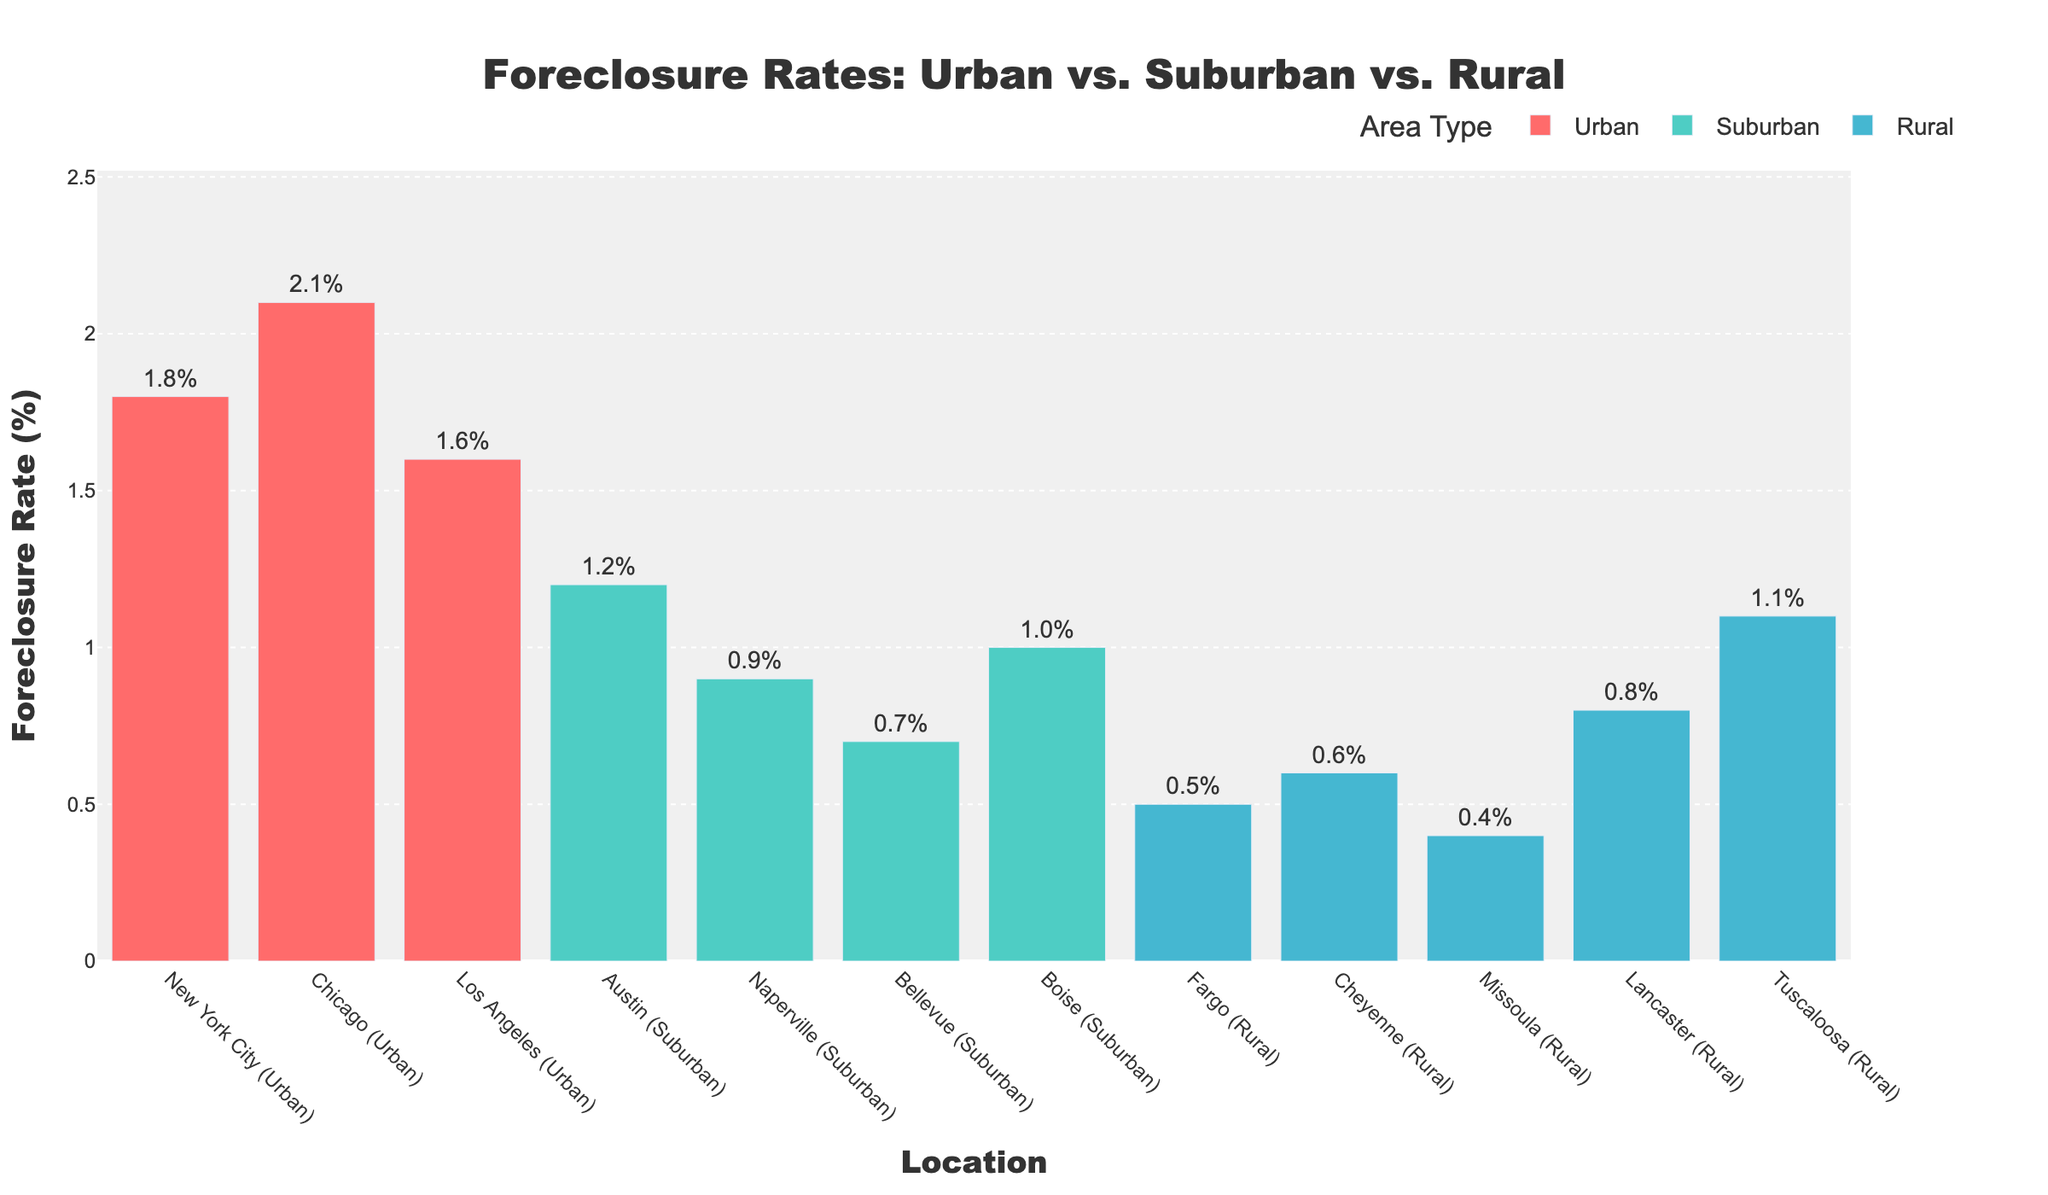Which area type has the highest foreclosure rate? By visually identifying the bars with the highest values and their corresponding area types, we see that the highest foreclosure rate is in Chicago, which is categorized as Urban.
Answer: Urban Which area type has the lowest foreclosure rate? By examining the shortest bars, we see that the lowest foreclosure rate is in Missoula, which is categorized as Rural.
Answer: Rural By how much does the foreclosure rate in Chicago exceed that in Bellevue? The foreclosure rate in Chicago is 2.1%, and in Bellevue, it is 0.7%. The difference can be calculated as 2.1% - 0.7% = 1.4%.
Answer: 1.4% What's the average foreclosure rate for suburban areas? The foreclosure rates for suburban areas are 1.2%, 0.9%, 0.7%, and 1.0%. Adding these up gives 3.8%, and dividing by 4 gives an average of 3.8% / 4 = 0.95%.
Answer: 0.95% Which location has a foreclosure rate closest to the average rate of rural areas? The foreclosure rates for rural areas are 0.5%, 0.6%, 0.4%, 0.8%, and 1.1%. Adding these and dividing by 5 gives an average of (0.5% + 0.6% + 0.4% + 0.8% + 1.1%) / 5 = 0.68%. Checking the closest rates, Cheyenne has a foreclosure rate of 0.6%, which is closest to 0.68%.
Answer: Cheyenne What is the range of foreclosure rates in urban areas? The foreclosure rates for urban areas are 1.8%, 2.1%, and 1.6%. The range is calculated as the difference between the maximum and minimum values: 2.1% - 1.6% = 0.5%.
Answer: 0.5% Which foreclosure rate in a rural area is higher than any in suburban areas? The highest foreclosure rate in suburban areas is 1.2% (Austin). The rural rate that is higher than 1.2% is 1.1% (None of them exceed 1.2%, no rural foreclosure rate is higher).
Answer: None How many urban, suburban, and rural locations are displayed, respectively? By counting the bars grouped by color, there are 3 urban, 4 suburban, and 5 rural locations displayed.
Answer: Urban: 3, Suburban: 4, Rural: 5 Which location has the median foreclosure rate for rural areas? The foreclosure rates for rural areas are 0.4%, 0.5%, 0.6%, 0.8%, and 1.1%. Arranging these in ascending order, we get 0.4%, 0.5%, 0.6%, 0.8%, and 1.1%. The median (middle) value is 0.6%, which corresponds to Cheyenne.
Answer: Cheyenne 